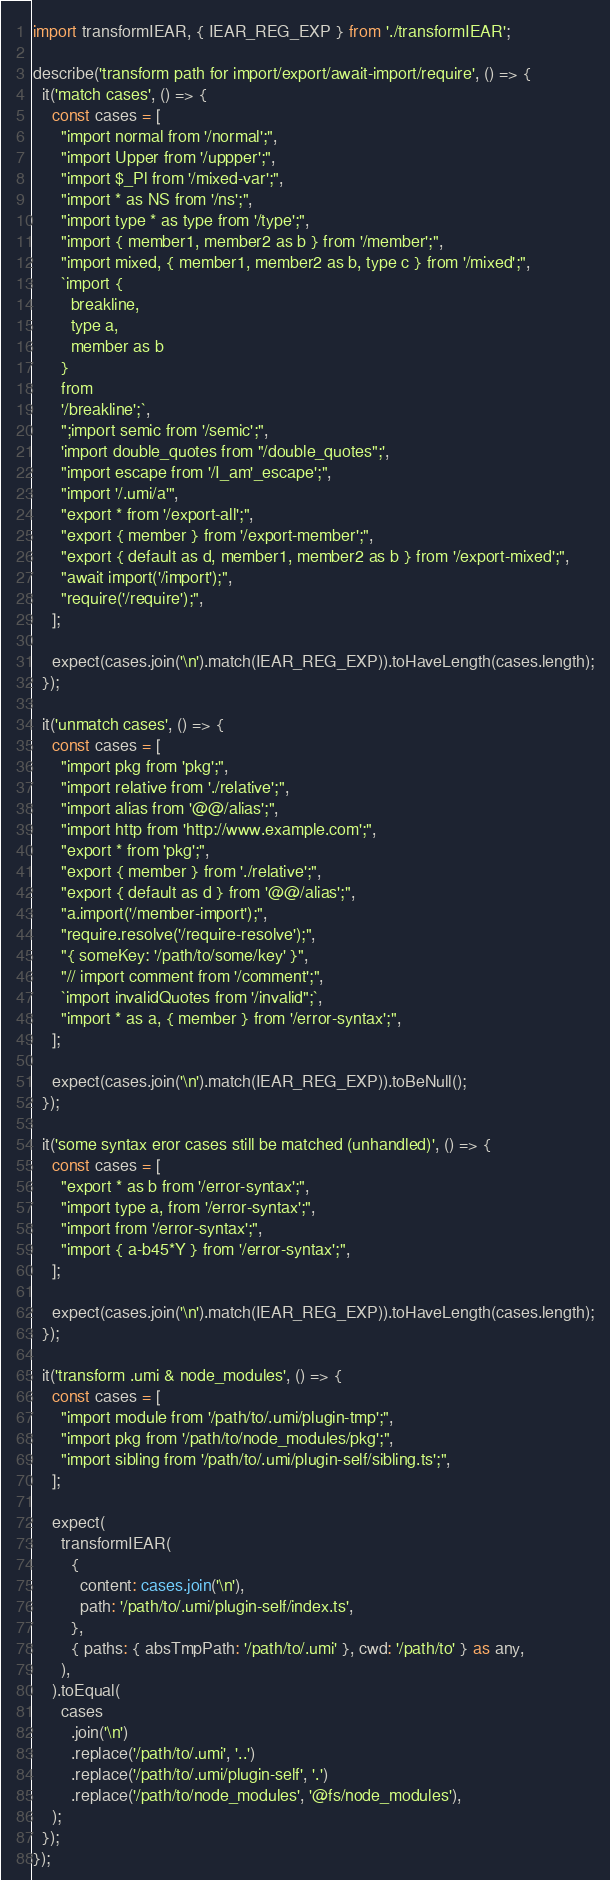Convert code to text. <code><loc_0><loc_0><loc_500><loc_500><_TypeScript_>import transformIEAR, { IEAR_REG_EXP } from './transformIEAR';

describe('transform path for import/export/await-import/require', () => {
  it('match cases', () => {
    const cases = [
      "import normal from '/normal';",
      "import Upper from '/uppper';",
      "import $_Pl from '/mixed-var';",
      "import * as NS from '/ns';",
      "import type * as type from '/type';",
      "import { member1, member2 as b } from '/member';",
      "import mixed, { member1, member2 as b, type c } from '/mixed';",
      `import {
        breakline,
        type a,
        member as b
      }
      from
      '/breakline';`,
      ";import semic from '/semic';",
      'import double_quotes from "/double_quotes";',
      "import escape from '/I_am'_escape';",
      "import '/.umi/a'",
      "export * from '/export-all';",
      "export { member } from '/export-member';",
      "export { default as d, member1, member2 as b } from '/export-mixed';",
      "await import('/import');",
      "require('/require');",
    ];

    expect(cases.join('\n').match(IEAR_REG_EXP)).toHaveLength(cases.length);
  });

  it('unmatch cases', () => {
    const cases = [
      "import pkg from 'pkg';",
      "import relative from './relative';",
      "import alias from '@@/alias';",
      "import http from 'http://www.example.com';",
      "export * from 'pkg';",
      "export { member } from './relative';",
      "export { default as d } from '@@/alias';",
      "a.import('/member-import');",
      "require.resolve('/require-resolve');",
      "{ someKey: '/path/to/some/key' }",
      "// import comment from '/comment';",
      `import invalidQuotes from '/invalid";`,
      "import * as a, { member } from '/error-syntax';",
    ];

    expect(cases.join('\n').match(IEAR_REG_EXP)).toBeNull();
  });

  it('some syntax eror cases still be matched (unhandled)', () => {
    const cases = [
      "export * as b from '/error-syntax';",
      "import type a, from '/error-syntax';",
      "import from '/error-syntax';",
      "import { a-b45*Y } from '/error-syntax';",
    ];

    expect(cases.join('\n').match(IEAR_REG_EXP)).toHaveLength(cases.length);
  });

  it('transform .umi & node_modules', () => {
    const cases = [
      "import module from '/path/to/.umi/plugin-tmp';",
      "import pkg from '/path/to/node_modules/pkg';",
      "import sibling from '/path/to/.umi/plugin-self/sibling.ts';",
    ];

    expect(
      transformIEAR(
        {
          content: cases.join('\n'),
          path: '/path/to/.umi/plugin-self/index.ts',
        },
        { paths: { absTmpPath: '/path/to/.umi' }, cwd: '/path/to' } as any,
      ),
    ).toEqual(
      cases
        .join('\n')
        .replace('/path/to/.umi', '..')
        .replace('/path/to/.umi/plugin-self', '.')
        .replace('/path/to/node_modules', '@fs/node_modules'),
    );
  });
});
</code> 